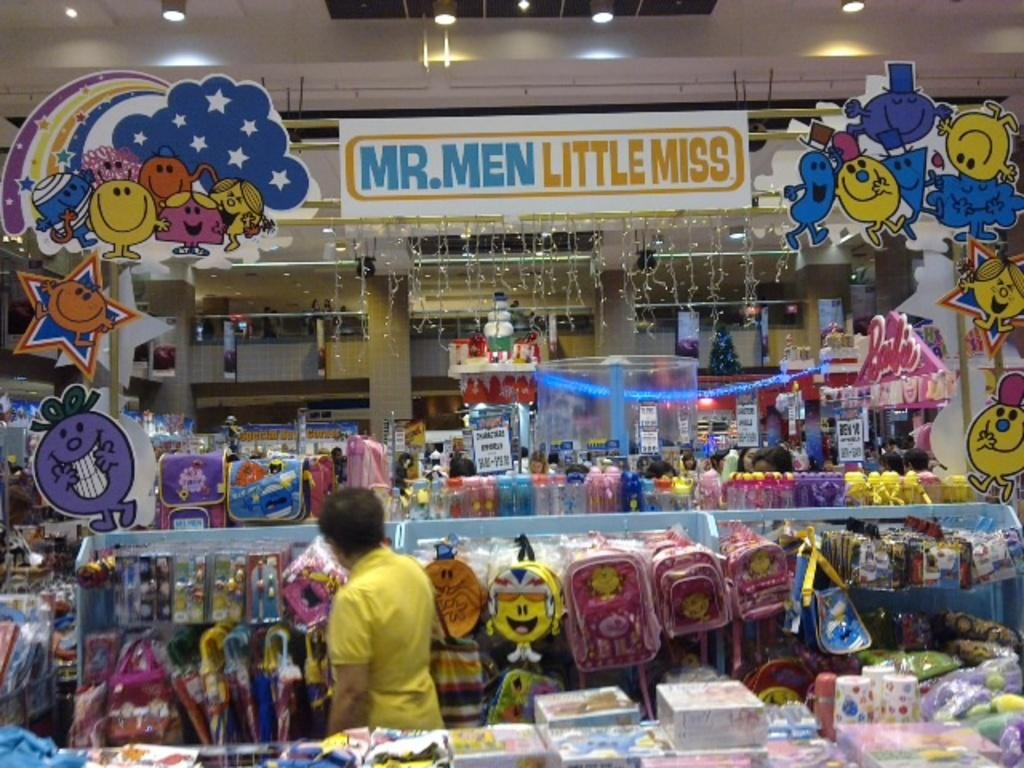<image>
Give a short and clear explanation of the subsequent image. A little kids store that is called Mr. Men Little Miss 